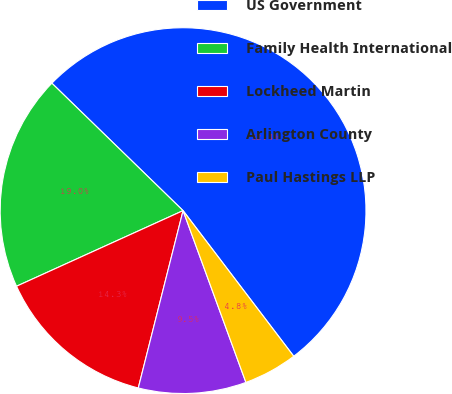Convert chart to OTSL. <chart><loc_0><loc_0><loc_500><loc_500><pie_chart><fcel>US Government<fcel>Family Health International<fcel>Lockheed Martin<fcel>Arlington County<fcel>Paul Hastings LLP<nl><fcel>52.39%<fcel>19.05%<fcel>14.28%<fcel>9.52%<fcel>4.76%<nl></chart> 